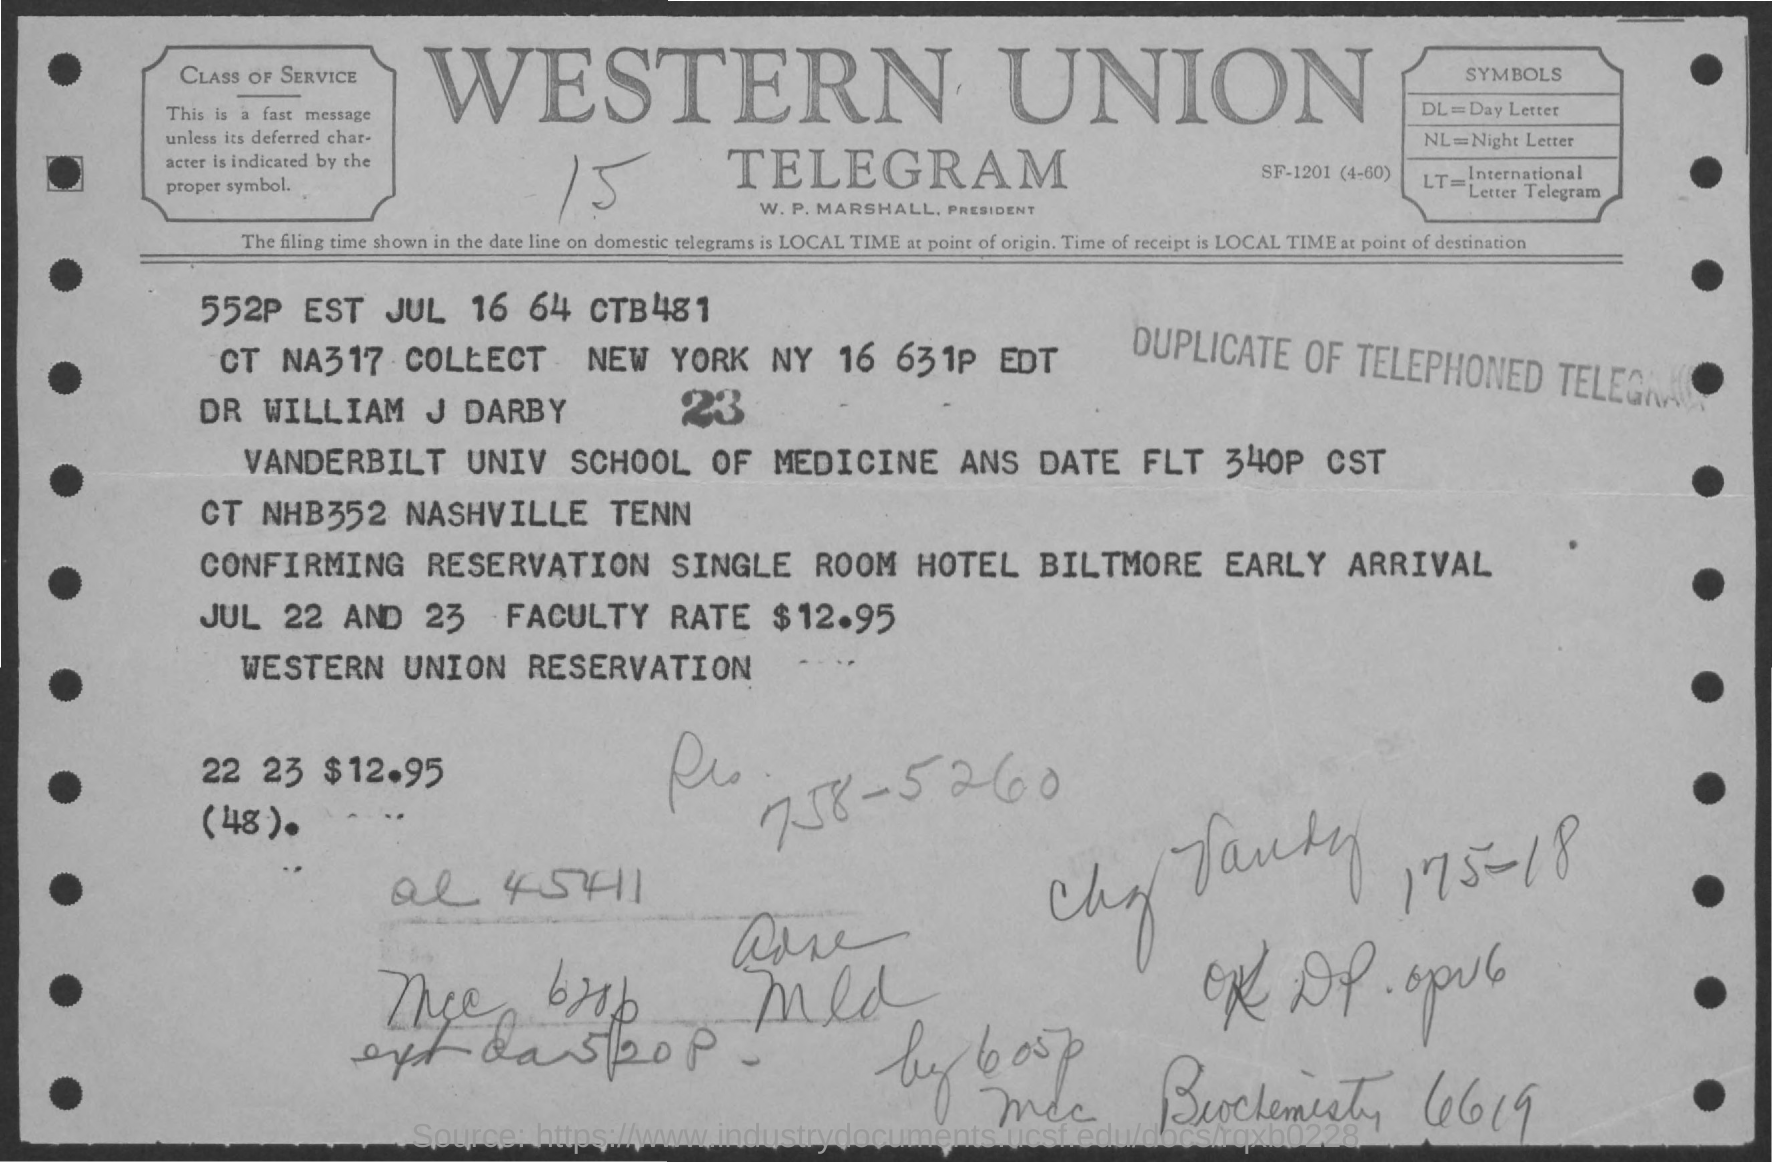What is the symbol of Day Letter?
Make the answer very short. Dl. 